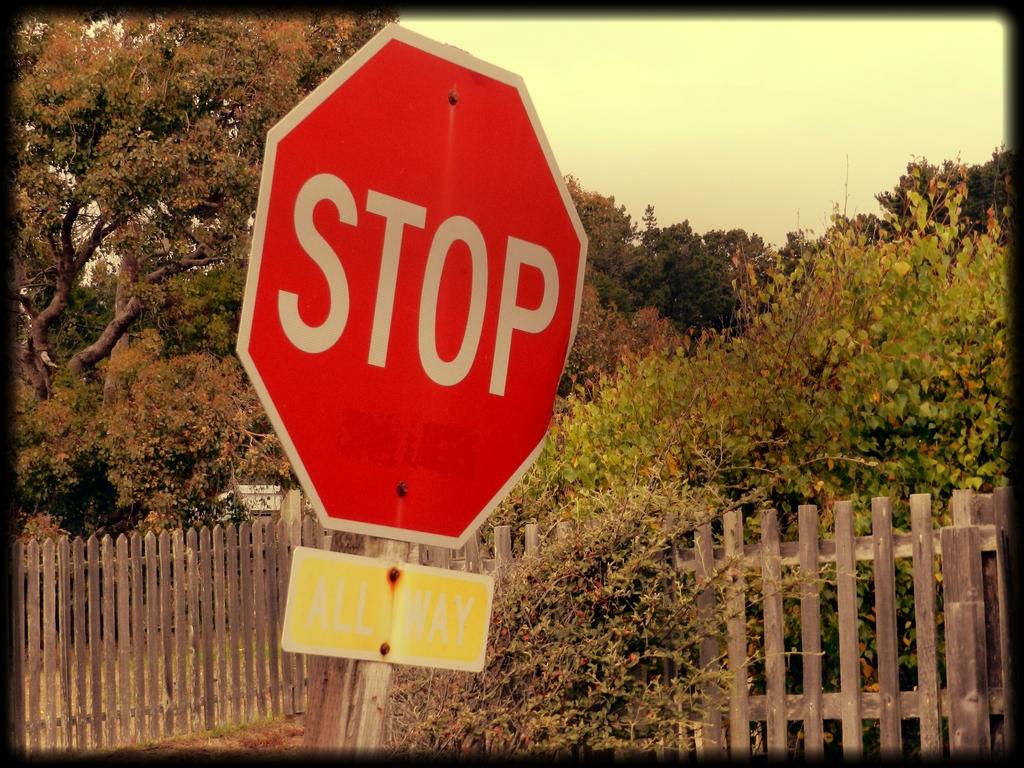What does the sign say to do?
Provide a short and direct response. Stop. What is the bottom sign?
Keep it short and to the point. All way. 